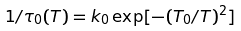Convert formula to latex. <formula><loc_0><loc_0><loc_500><loc_500>1 / \tau _ { 0 } ( T ) = k _ { 0 } \exp [ - ( T _ { 0 } / T ) ^ { 2 } ]</formula> 